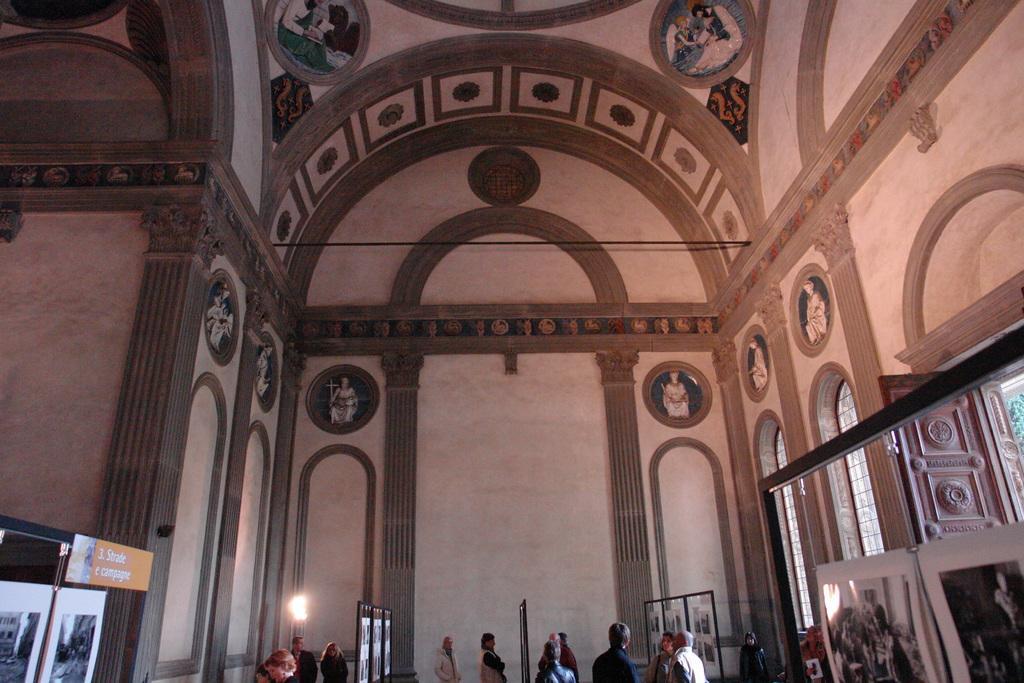Describe this image in one or two sentences. In this image, I can see the inside view of a building. There are sculptures on the wall. At the bottom of the image, there are groups of people, boards and light. On the right side of the image, I can see a wooden door. 